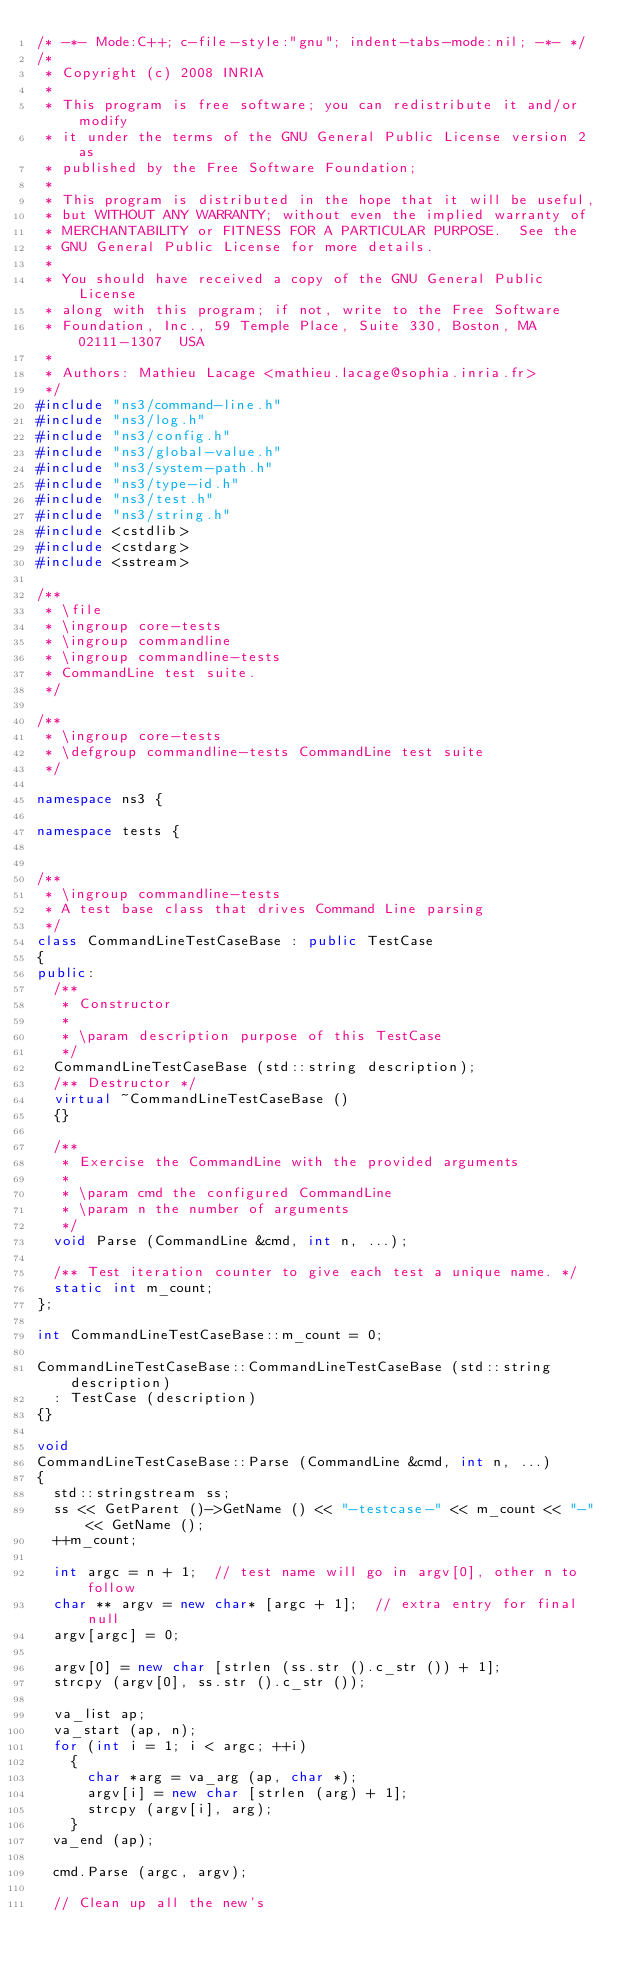<code> <loc_0><loc_0><loc_500><loc_500><_C++_>/* -*- Mode:C++; c-file-style:"gnu"; indent-tabs-mode:nil; -*- */
/*
 * Copyright (c) 2008 INRIA
 *
 * This program is free software; you can redistribute it and/or modify
 * it under the terms of the GNU General Public License version 2 as
 * published by the Free Software Foundation;
 *
 * This program is distributed in the hope that it will be useful,
 * but WITHOUT ANY WARRANTY; without even the implied warranty of
 * MERCHANTABILITY or FITNESS FOR A PARTICULAR PURPOSE.  See the
 * GNU General Public License for more details.
 *
 * You should have received a copy of the GNU General Public License
 * along with this program; if not, write to the Free Software
 * Foundation, Inc., 59 Temple Place, Suite 330, Boston, MA  02111-1307  USA
 *
 * Authors: Mathieu Lacage <mathieu.lacage@sophia.inria.fr>
 */
#include "ns3/command-line.h"
#include "ns3/log.h"
#include "ns3/config.h"
#include "ns3/global-value.h"
#include "ns3/system-path.h"
#include "ns3/type-id.h"
#include "ns3/test.h"
#include "ns3/string.h"
#include <cstdlib>
#include <cstdarg>
#include <sstream>

/**
 * \file
 * \ingroup core-tests
 * \ingroup commandline
 * \ingroup commandline-tests
 * CommandLine test suite.
 */

/**
 * \ingroup core-tests
 * \defgroup commandline-tests CommandLine test suite
 */

namespace ns3 {

namespace tests {


/**
 * \ingroup commandline-tests
 * A test base class that drives Command Line parsing
 */
class CommandLineTestCaseBase : public TestCase
{
public:
  /**
   * Constructor
   *
   * \param description purpose of this TestCase
   */
  CommandLineTestCaseBase (std::string description);
  /** Destructor */
  virtual ~CommandLineTestCaseBase ()
  {}

  /**
   * Exercise the CommandLine with the provided arguments
   *
   * \param cmd the configured CommandLine
   * \param n the number of arguments
   */
  void Parse (CommandLine &cmd, int n, ...);

  /** Test iteration counter to give each test a unique name. */
  static int m_count;
};

int CommandLineTestCaseBase::m_count = 0;

CommandLineTestCaseBase::CommandLineTestCaseBase (std::string description)
  : TestCase (description)
{}

void
CommandLineTestCaseBase::Parse (CommandLine &cmd, int n, ...)
{
  std::stringstream ss;
  ss << GetParent ()->GetName () << "-testcase-" << m_count << "-" << GetName ();
  ++m_count;

  int argc = n + 1;  // test name will go in argv[0], other n to follow
  char ** argv = new char* [argc + 1];  // extra entry for final null
  argv[argc] = 0;

  argv[0] = new char [strlen (ss.str ().c_str ()) + 1];
  strcpy (argv[0], ss.str ().c_str ());

  va_list ap;
  va_start (ap, n);
  for (int i = 1; i < argc; ++i)
    {
      char *arg = va_arg (ap, char *);
      argv[i] = new char [strlen (arg) + 1];
      strcpy (argv[i], arg);
    }
  va_end (ap);

  cmd.Parse (argc, argv);

  // Clean up all the new's</code> 